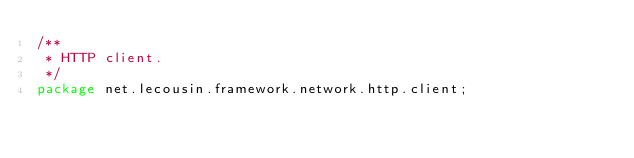Convert code to text. <code><loc_0><loc_0><loc_500><loc_500><_Java_>/**
 * HTTP client.
 */
package net.lecousin.framework.network.http.client;
</code> 